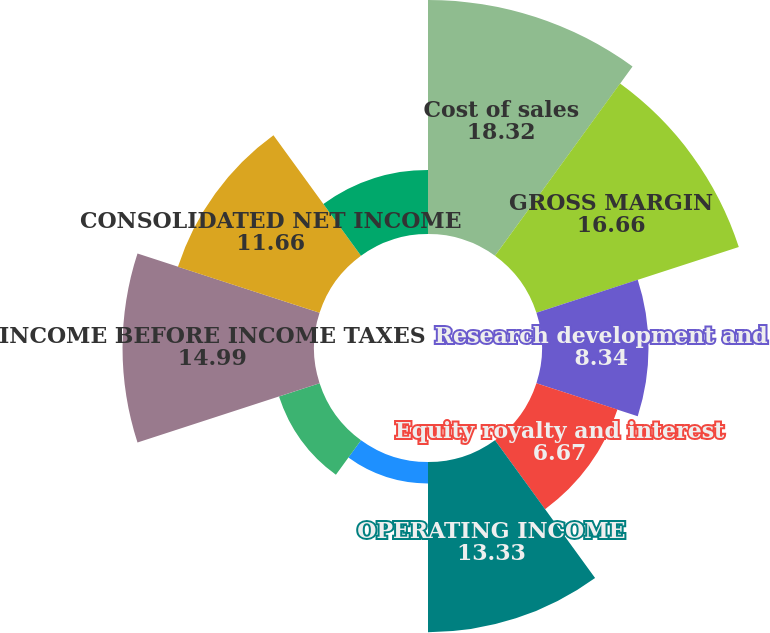Convert chart. <chart><loc_0><loc_0><loc_500><loc_500><pie_chart><fcel>Cost of sales<fcel>GROSS MARGIN<fcel>Research development and<fcel>Equity royalty and interest<fcel>OPERATING INCOME<fcel>Interest income<fcel>Interest expense<fcel>INCOME BEFORE INCOME TAXES<fcel>CONSOLIDATED NET INCOME<fcel>Less Net income attributable<nl><fcel>18.32%<fcel>16.66%<fcel>8.34%<fcel>6.67%<fcel>13.33%<fcel>1.68%<fcel>3.34%<fcel>14.99%<fcel>11.66%<fcel>5.01%<nl></chart> 